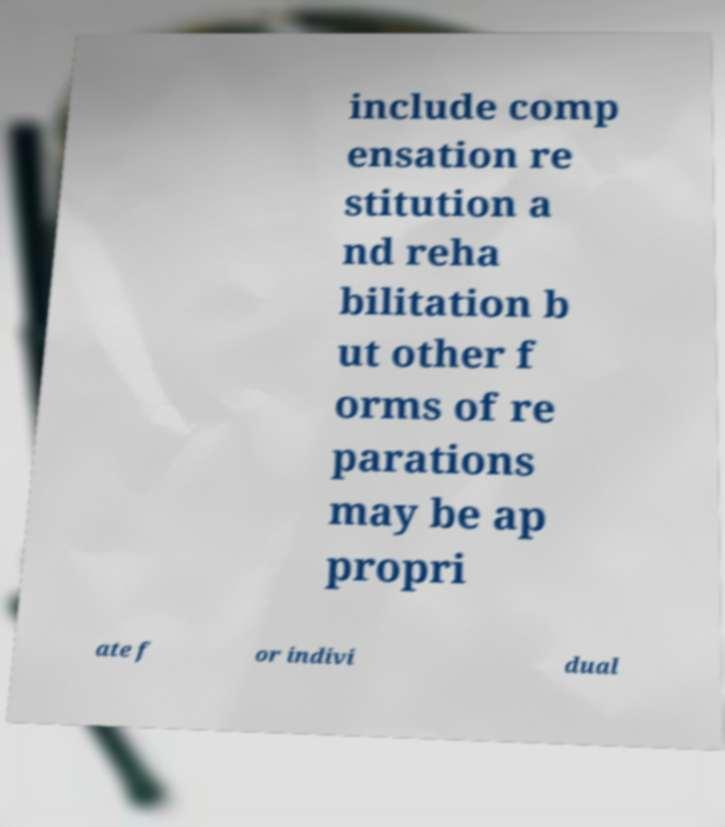Can you accurately transcribe the text from the provided image for me? include comp ensation re stitution a nd reha bilitation b ut other f orms of re parations may be ap propri ate f or indivi dual 